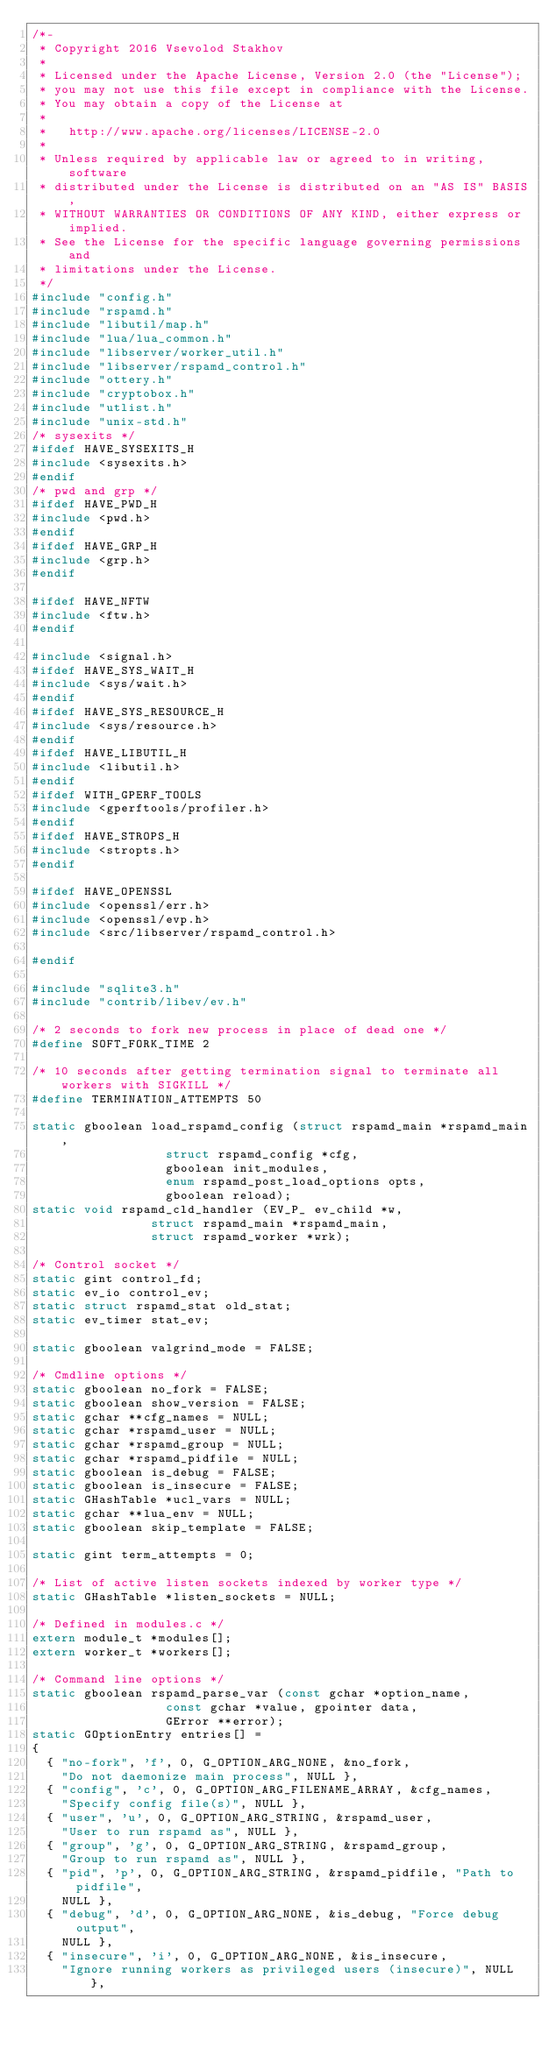Convert code to text. <code><loc_0><loc_0><loc_500><loc_500><_C_>/*-
 * Copyright 2016 Vsevolod Stakhov
 *
 * Licensed under the Apache License, Version 2.0 (the "License");
 * you may not use this file except in compliance with the License.
 * You may obtain a copy of the License at
 *
 *   http://www.apache.org/licenses/LICENSE-2.0
 *
 * Unless required by applicable law or agreed to in writing, software
 * distributed under the License is distributed on an "AS IS" BASIS,
 * WITHOUT WARRANTIES OR CONDITIONS OF ANY KIND, either express or implied.
 * See the License for the specific language governing permissions and
 * limitations under the License.
 */
#include "config.h"
#include "rspamd.h"
#include "libutil/map.h"
#include "lua/lua_common.h"
#include "libserver/worker_util.h"
#include "libserver/rspamd_control.h"
#include "ottery.h"
#include "cryptobox.h"
#include "utlist.h"
#include "unix-std.h"
/* sysexits */
#ifdef HAVE_SYSEXITS_H
#include <sysexits.h>
#endif
/* pwd and grp */
#ifdef HAVE_PWD_H
#include <pwd.h>
#endif
#ifdef HAVE_GRP_H
#include <grp.h>
#endif

#ifdef HAVE_NFTW
#include <ftw.h>
#endif

#include <signal.h>
#ifdef HAVE_SYS_WAIT_H
#include <sys/wait.h>
#endif
#ifdef HAVE_SYS_RESOURCE_H
#include <sys/resource.h>
#endif
#ifdef HAVE_LIBUTIL_H
#include <libutil.h>
#endif
#ifdef WITH_GPERF_TOOLS
#include <gperftools/profiler.h>
#endif
#ifdef HAVE_STROPS_H
#include <stropts.h>
#endif

#ifdef HAVE_OPENSSL
#include <openssl/err.h>
#include <openssl/evp.h>
#include <src/libserver/rspamd_control.h>

#endif

#include "sqlite3.h"
#include "contrib/libev/ev.h"

/* 2 seconds to fork new process in place of dead one */
#define SOFT_FORK_TIME 2

/* 10 seconds after getting termination signal to terminate all workers with SIGKILL */
#define TERMINATION_ATTEMPTS 50

static gboolean load_rspamd_config (struct rspamd_main *rspamd_main,
									struct rspamd_config *cfg,
									gboolean init_modules,
									enum rspamd_post_load_options opts,
									gboolean reload);
static void rspamd_cld_handler (EV_P_ ev_child *w,
								struct rspamd_main *rspamd_main,
								struct rspamd_worker *wrk);

/* Control socket */
static gint control_fd;
static ev_io control_ev;
static struct rspamd_stat old_stat;
static ev_timer stat_ev;

static gboolean valgrind_mode = FALSE;

/* Cmdline options */
static gboolean no_fork = FALSE;
static gboolean show_version = FALSE;
static gchar **cfg_names = NULL;
static gchar *rspamd_user = NULL;
static gchar *rspamd_group = NULL;
static gchar *rspamd_pidfile = NULL;
static gboolean is_debug = FALSE;
static gboolean is_insecure = FALSE;
static GHashTable *ucl_vars = NULL;
static gchar **lua_env = NULL;
static gboolean skip_template = FALSE;

static gint term_attempts = 0;

/* List of active listen sockets indexed by worker type */
static GHashTable *listen_sockets = NULL;

/* Defined in modules.c */
extern module_t *modules[];
extern worker_t *workers[];

/* Command line options */
static gboolean rspamd_parse_var (const gchar *option_name,
								  const gchar *value, gpointer data,
								  GError **error);
static GOptionEntry entries[] =
{
	{ "no-fork", 'f', 0, G_OPTION_ARG_NONE, &no_fork,
	  "Do not daemonize main process", NULL },
	{ "config", 'c', 0, G_OPTION_ARG_FILENAME_ARRAY, &cfg_names,
	  "Specify config file(s)", NULL },
	{ "user", 'u', 0, G_OPTION_ARG_STRING, &rspamd_user,
	  "User to run rspamd as", NULL },
	{ "group", 'g', 0, G_OPTION_ARG_STRING, &rspamd_group,
	  "Group to run rspamd as", NULL },
	{ "pid", 'p', 0, G_OPTION_ARG_STRING, &rspamd_pidfile, "Path to pidfile",
	  NULL },
	{ "debug", 'd', 0, G_OPTION_ARG_NONE, &is_debug, "Force debug output",
	  NULL },
	{ "insecure", 'i', 0, G_OPTION_ARG_NONE, &is_insecure,
	  "Ignore running workers as privileged users (insecure)", NULL },</code> 